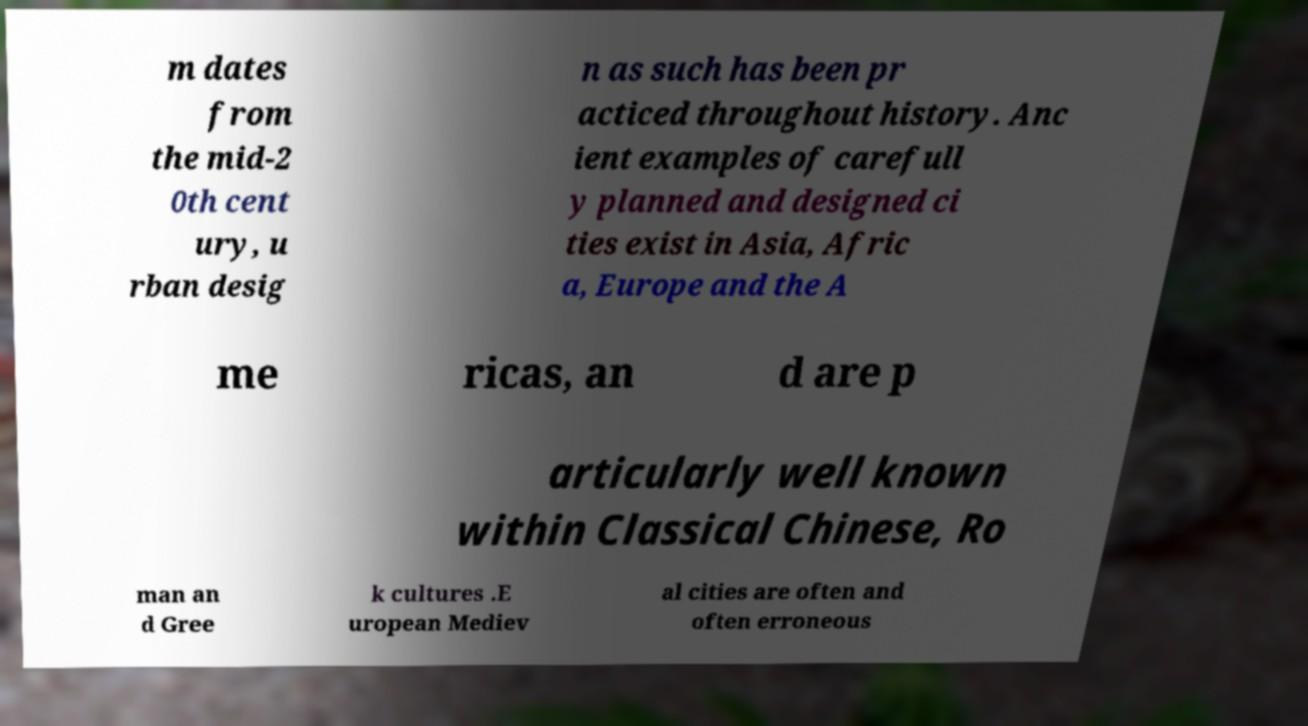What messages or text are displayed in this image? I need them in a readable, typed format. m dates from the mid-2 0th cent ury, u rban desig n as such has been pr acticed throughout history. Anc ient examples of carefull y planned and designed ci ties exist in Asia, Afric a, Europe and the A me ricas, an d are p articularly well known within Classical Chinese, Ro man an d Gree k cultures .E uropean Mediev al cities are often and often erroneous 